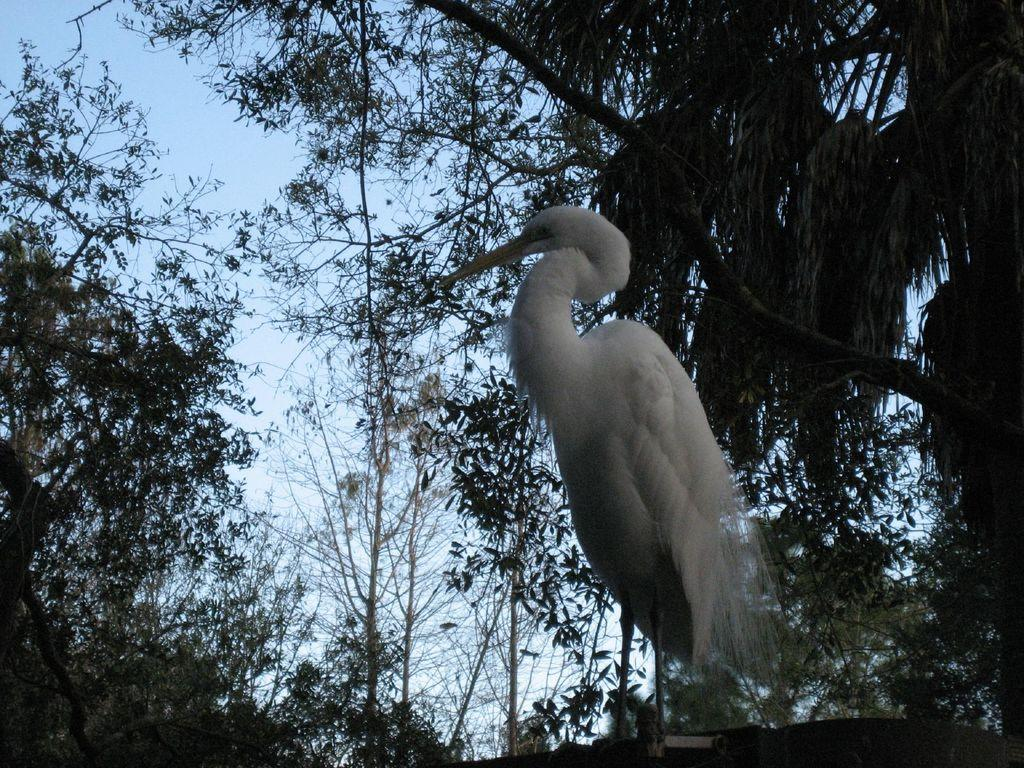What type of animal can be seen in the image? There is a bird in the image. What is the color of the bird? The bird is white in color. What can be seen in the background of the image? There are trees and the sky visible in the background of the image. What type of salt is being used to season the yam in the image? There is no yam or salt present in the image; it features a white bird and a background with trees and the sky. 